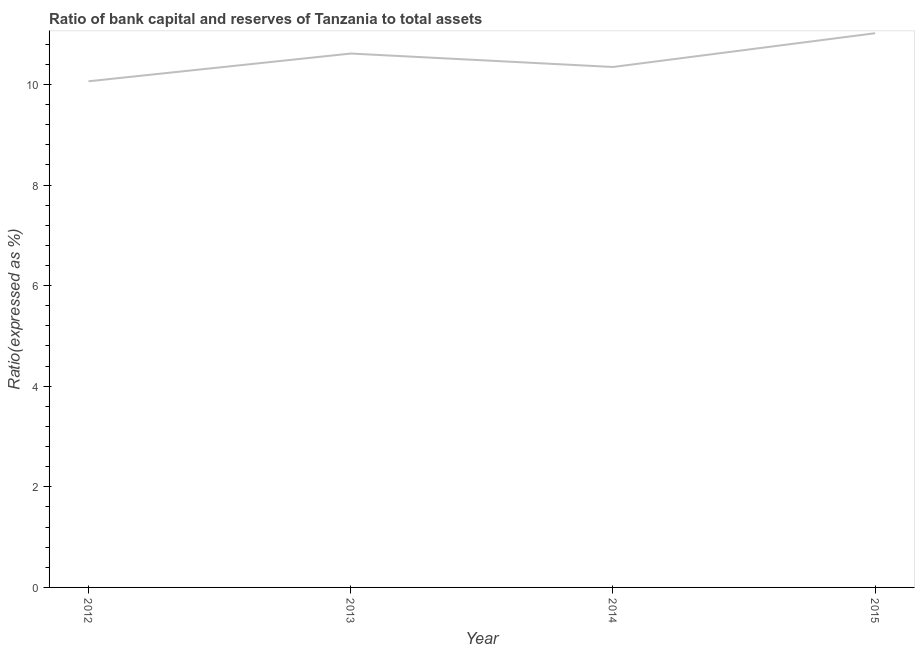What is the bank capital to assets ratio in 2012?
Your response must be concise. 10.06. Across all years, what is the maximum bank capital to assets ratio?
Provide a short and direct response. 11.02. Across all years, what is the minimum bank capital to assets ratio?
Give a very brief answer. 10.06. In which year was the bank capital to assets ratio maximum?
Ensure brevity in your answer.  2015. What is the sum of the bank capital to assets ratio?
Your answer should be very brief. 42.04. What is the difference between the bank capital to assets ratio in 2012 and 2013?
Give a very brief answer. -0.55. What is the average bank capital to assets ratio per year?
Keep it short and to the point. 10.51. What is the median bank capital to assets ratio?
Give a very brief answer. 10.48. In how many years, is the bank capital to assets ratio greater than 6.8 %?
Your answer should be compact. 4. What is the ratio of the bank capital to assets ratio in 2012 to that in 2014?
Give a very brief answer. 0.97. Is the bank capital to assets ratio in 2014 less than that in 2015?
Give a very brief answer. Yes. Is the difference between the bank capital to assets ratio in 2013 and 2015 greater than the difference between any two years?
Your answer should be very brief. No. What is the difference between the highest and the second highest bank capital to assets ratio?
Offer a very short reply. 0.4. Is the sum of the bank capital to assets ratio in 2014 and 2015 greater than the maximum bank capital to assets ratio across all years?
Your answer should be very brief. Yes. What is the difference between the highest and the lowest bank capital to assets ratio?
Offer a terse response. 0.96. In how many years, is the bank capital to assets ratio greater than the average bank capital to assets ratio taken over all years?
Your response must be concise. 2. Does the bank capital to assets ratio monotonically increase over the years?
Give a very brief answer. No. Does the graph contain grids?
Keep it short and to the point. No. What is the title of the graph?
Provide a succinct answer. Ratio of bank capital and reserves of Tanzania to total assets. What is the label or title of the Y-axis?
Ensure brevity in your answer.  Ratio(expressed as %). What is the Ratio(expressed as %) in 2012?
Offer a terse response. 10.06. What is the Ratio(expressed as %) in 2013?
Your answer should be very brief. 10.61. What is the Ratio(expressed as %) in 2014?
Provide a succinct answer. 10.35. What is the Ratio(expressed as %) in 2015?
Make the answer very short. 11.02. What is the difference between the Ratio(expressed as %) in 2012 and 2013?
Give a very brief answer. -0.55. What is the difference between the Ratio(expressed as %) in 2012 and 2014?
Make the answer very short. -0.28. What is the difference between the Ratio(expressed as %) in 2012 and 2015?
Ensure brevity in your answer.  -0.96. What is the difference between the Ratio(expressed as %) in 2013 and 2014?
Provide a short and direct response. 0.27. What is the difference between the Ratio(expressed as %) in 2013 and 2015?
Give a very brief answer. -0.4. What is the difference between the Ratio(expressed as %) in 2014 and 2015?
Provide a succinct answer. -0.67. What is the ratio of the Ratio(expressed as %) in 2012 to that in 2013?
Give a very brief answer. 0.95. What is the ratio of the Ratio(expressed as %) in 2013 to that in 2014?
Offer a very short reply. 1.03. What is the ratio of the Ratio(expressed as %) in 2013 to that in 2015?
Your response must be concise. 0.96. What is the ratio of the Ratio(expressed as %) in 2014 to that in 2015?
Your answer should be compact. 0.94. 